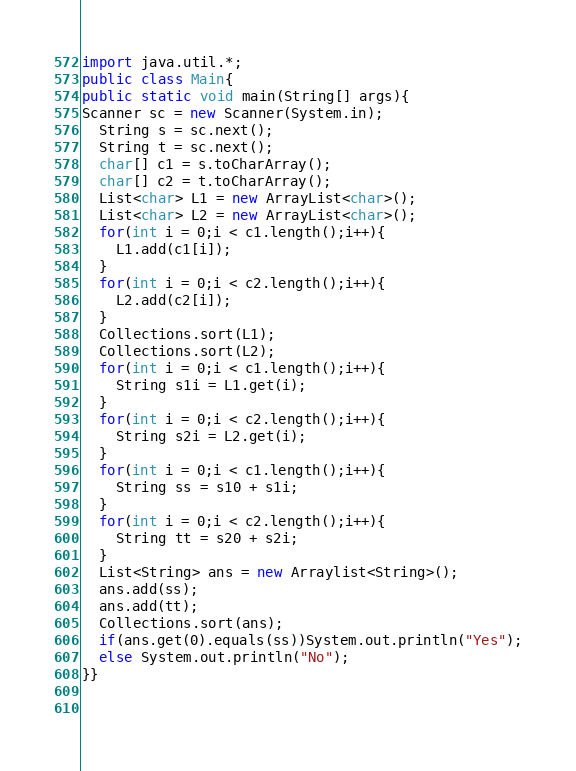Convert code to text. <code><loc_0><loc_0><loc_500><loc_500><_Java_>import java.util.*;
public class Main{
public static void main(String[] args){
Scanner sc = new Scanner(System.in);
  String s = sc.next();
  String t = sc.next();
  char[] c1 = s.toCharArray();
  char[] c2 = t.toCharArray();
  List<char> L1 = new ArrayList<char>();
  List<char> L2 = new ArrayList<char>();
  for(int i = 0;i < c1.length();i++){
    L1.add(c1[i]);
  }
  for(int i = 0;i < c2.length();i++){
    L2.add(c2[i]);
  }
  Collections.sort(L1);
  Collections.sort(L2);
  for(int i = 0;i < c1.length();i++){
    String s1i = L1.get(i);
  }
  for(int i = 0;i < c2.length();i++){
    String s2i = L2.get(i);
  }
  for(int i = 0;i < c1.length();i++){
    String ss = s10 + s1i;
  }
  for(int i = 0;i < c2.length();i++){
    String tt = s20 + s2i;
  }
  List<String> ans = new Arraylist<String>();
  ans.add(ss);
  ans.add(tt);
  Collections.sort(ans);
  if(ans.get(0).equals(ss))System.out.println("Yes");
  else System.out.println("No");
}}
  
    
</code> 